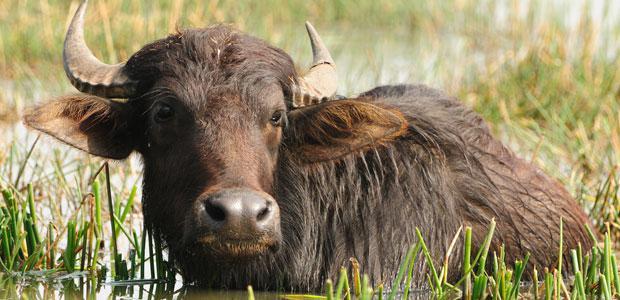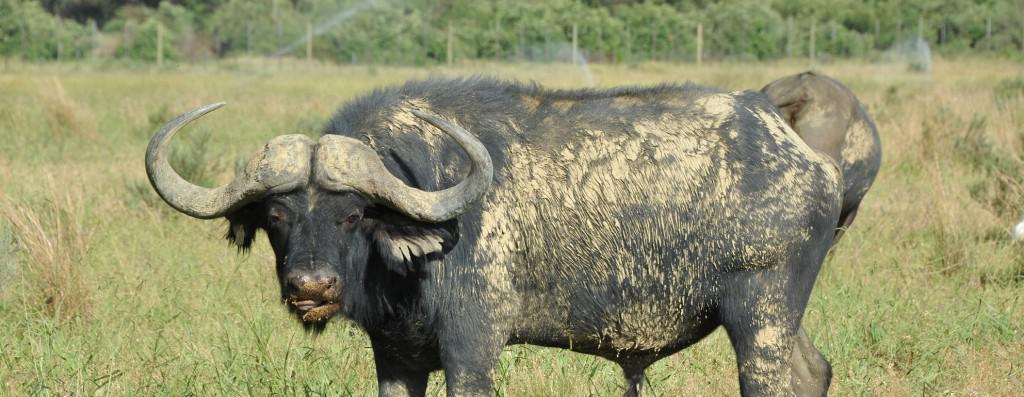The first image is the image on the left, the second image is the image on the right. Analyze the images presented: Is the assertion "There are two buffalo." valid? Answer yes or no. Yes. The first image is the image on the left, the second image is the image on the right. Analyze the images presented: Is the assertion "There is a total of 1 male African buffalo, accompanied by a total of 1 other African buffalo." valid? Answer yes or no. Yes. 